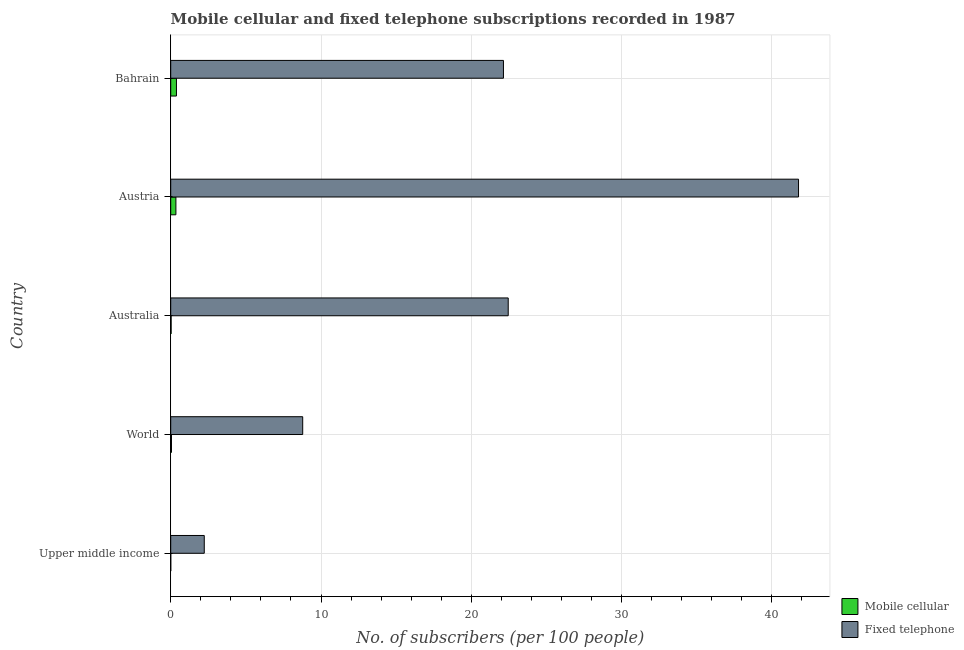How many groups of bars are there?
Give a very brief answer. 5. How many bars are there on the 5th tick from the top?
Your answer should be compact. 2. What is the label of the 1st group of bars from the top?
Offer a very short reply. Bahrain. In how many cases, is the number of bars for a given country not equal to the number of legend labels?
Provide a short and direct response. 0. What is the number of mobile cellular subscribers in Austria?
Give a very brief answer. 0.35. Across all countries, what is the maximum number of fixed telephone subscribers?
Make the answer very short. 41.78. Across all countries, what is the minimum number of mobile cellular subscribers?
Provide a succinct answer. 0. In which country was the number of mobile cellular subscribers maximum?
Offer a very short reply. Bahrain. In which country was the number of mobile cellular subscribers minimum?
Keep it short and to the point. Upper middle income. What is the total number of fixed telephone subscribers in the graph?
Your response must be concise. 97.39. What is the difference between the number of mobile cellular subscribers in Australia and that in Austria?
Your answer should be compact. -0.32. What is the difference between the number of mobile cellular subscribers in Australia and the number of fixed telephone subscribers in Bahrain?
Ensure brevity in your answer.  -22.11. What is the average number of fixed telephone subscribers per country?
Your answer should be compact. 19.48. What is the difference between the number of mobile cellular subscribers and number of fixed telephone subscribers in Bahrain?
Make the answer very short. -21.76. In how many countries, is the number of mobile cellular subscribers greater than 2 ?
Keep it short and to the point. 0. What is the ratio of the number of fixed telephone subscribers in Australia to that in World?
Your answer should be very brief. 2.56. Is the number of mobile cellular subscribers in Australia less than that in Upper middle income?
Your answer should be compact. No. Is the difference between the number of fixed telephone subscribers in Australia and Bahrain greater than the difference between the number of mobile cellular subscribers in Australia and Bahrain?
Offer a very short reply. Yes. What is the difference between the highest and the second highest number of fixed telephone subscribers?
Offer a very short reply. 19.32. What is the difference between the highest and the lowest number of mobile cellular subscribers?
Provide a succinct answer. 0.38. Is the sum of the number of fixed telephone subscribers in Bahrain and Upper middle income greater than the maximum number of mobile cellular subscribers across all countries?
Offer a very short reply. Yes. What does the 2nd bar from the top in World represents?
Offer a very short reply. Mobile cellular. What does the 1st bar from the bottom in Upper middle income represents?
Give a very brief answer. Mobile cellular. How many countries are there in the graph?
Make the answer very short. 5. What is the difference between two consecutive major ticks on the X-axis?
Provide a succinct answer. 10. Are the values on the major ticks of X-axis written in scientific E-notation?
Your answer should be very brief. No. Does the graph contain any zero values?
Offer a very short reply. No. How many legend labels are there?
Your response must be concise. 2. How are the legend labels stacked?
Make the answer very short. Vertical. What is the title of the graph?
Your response must be concise. Mobile cellular and fixed telephone subscriptions recorded in 1987. Does "Technicians" appear as one of the legend labels in the graph?
Your answer should be very brief. No. What is the label or title of the X-axis?
Ensure brevity in your answer.  No. of subscribers (per 100 people). What is the label or title of the Y-axis?
Your answer should be compact. Country. What is the No. of subscribers (per 100 people) in Mobile cellular in Upper middle income?
Make the answer very short. 0. What is the No. of subscribers (per 100 people) in Fixed telephone in Upper middle income?
Your response must be concise. 2.23. What is the No. of subscribers (per 100 people) of Mobile cellular in World?
Your response must be concise. 0.05. What is the No. of subscribers (per 100 people) of Fixed telephone in World?
Your answer should be compact. 8.78. What is the No. of subscribers (per 100 people) of Mobile cellular in Australia?
Offer a very short reply. 0.03. What is the No. of subscribers (per 100 people) in Fixed telephone in Australia?
Your response must be concise. 22.46. What is the No. of subscribers (per 100 people) in Mobile cellular in Austria?
Make the answer very short. 0.35. What is the No. of subscribers (per 100 people) in Fixed telephone in Austria?
Offer a terse response. 41.78. What is the No. of subscribers (per 100 people) of Mobile cellular in Bahrain?
Your answer should be very brief. 0.38. What is the No. of subscribers (per 100 people) of Fixed telephone in Bahrain?
Your response must be concise. 22.14. Across all countries, what is the maximum No. of subscribers (per 100 people) of Mobile cellular?
Ensure brevity in your answer.  0.38. Across all countries, what is the maximum No. of subscribers (per 100 people) of Fixed telephone?
Provide a succinct answer. 41.78. Across all countries, what is the minimum No. of subscribers (per 100 people) in Mobile cellular?
Your answer should be compact. 0. Across all countries, what is the minimum No. of subscribers (per 100 people) of Fixed telephone?
Your answer should be compact. 2.23. What is the total No. of subscribers (per 100 people) in Mobile cellular in the graph?
Offer a very short reply. 0.81. What is the total No. of subscribers (per 100 people) in Fixed telephone in the graph?
Give a very brief answer. 97.39. What is the difference between the No. of subscribers (per 100 people) in Mobile cellular in Upper middle income and that in World?
Ensure brevity in your answer.  -0.05. What is the difference between the No. of subscribers (per 100 people) in Fixed telephone in Upper middle income and that in World?
Give a very brief answer. -6.55. What is the difference between the No. of subscribers (per 100 people) of Mobile cellular in Upper middle income and that in Australia?
Give a very brief answer. -0.03. What is the difference between the No. of subscribers (per 100 people) of Fixed telephone in Upper middle income and that in Australia?
Offer a very short reply. -20.23. What is the difference between the No. of subscribers (per 100 people) in Mobile cellular in Upper middle income and that in Austria?
Your answer should be very brief. -0.34. What is the difference between the No. of subscribers (per 100 people) of Fixed telephone in Upper middle income and that in Austria?
Offer a terse response. -39.54. What is the difference between the No. of subscribers (per 100 people) in Mobile cellular in Upper middle income and that in Bahrain?
Provide a succinct answer. -0.38. What is the difference between the No. of subscribers (per 100 people) in Fixed telephone in Upper middle income and that in Bahrain?
Make the answer very short. -19.91. What is the difference between the No. of subscribers (per 100 people) in Mobile cellular in World and that in Australia?
Provide a succinct answer. 0.02. What is the difference between the No. of subscribers (per 100 people) in Fixed telephone in World and that in Australia?
Your answer should be compact. -13.68. What is the difference between the No. of subscribers (per 100 people) of Mobile cellular in World and that in Austria?
Your response must be concise. -0.29. What is the difference between the No. of subscribers (per 100 people) in Fixed telephone in World and that in Austria?
Your answer should be compact. -32.99. What is the difference between the No. of subscribers (per 100 people) of Mobile cellular in World and that in Bahrain?
Provide a short and direct response. -0.33. What is the difference between the No. of subscribers (per 100 people) in Fixed telephone in World and that in Bahrain?
Offer a terse response. -13.36. What is the difference between the No. of subscribers (per 100 people) in Mobile cellular in Australia and that in Austria?
Ensure brevity in your answer.  -0.32. What is the difference between the No. of subscribers (per 100 people) in Fixed telephone in Australia and that in Austria?
Offer a very short reply. -19.32. What is the difference between the No. of subscribers (per 100 people) of Mobile cellular in Australia and that in Bahrain?
Make the answer very short. -0.35. What is the difference between the No. of subscribers (per 100 people) in Fixed telephone in Australia and that in Bahrain?
Give a very brief answer. 0.32. What is the difference between the No. of subscribers (per 100 people) in Mobile cellular in Austria and that in Bahrain?
Make the answer very short. -0.04. What is the difference between the No. of subscribers (per 100 people) of Fixed telephone in Austria and that in Bahrain?
Keep it short and to the point. 19.64. What is the difference between the No. of subscribers (per 100 people) of Mobile cellular in Upper middle income and the No. of subscribers (per 100 people) of Fixed telephone in World?
Your answer should be very brief. -8.78. What is the difference between the No. of subscribers (per 100 people) in Mobile cellular in Upper middle income and the No. of subscribers (per 100 people) in Fixed telephone in Australia?
Offer a very short reply. -22.46. What is the difference between the No. of subscribers (per 100 people) in Mobile cellular in Upper middle income and the No. of subscribers (per 100 people) in Fixed telephone in Austria?
Your answer should be very brief. -41.77. What is the difference between the No. of subscribers (per 100 people) in Mobile cellular in Upper middle income and the No. of subscribers (per 100 people) in Fixed telephone in Bahrain?
Your answer should be compact. -22.14. What is the difference between the No. of subscribers (per 100 people) in Mobile cellular in World and the No. of subscribers (per 100 people) in Fixed telephone in Australia?
Offer a terse response. -22.41. What is the difference between the No. of subscribers (per 100 people) of Mobile cellular in World and the No. of subscribers (per 100 people) of Fixed telephone in Austria?
Offer a very short reply. -41.73. What is the difference between the No. of subscribers (per 100 people) in Mobile cellular in World and the No. of subscribers (per 100 people) in Fixed telephone in Bahrain?
Give a very brief answer. -22.09. What is the difference between the No. of subscribers (per 100 people) in Mobile cellular in Australia and the No. of subscribers (per 100 people) in Fixed telephone in Austria?
Provide a short and direct response. -41.75. What is the difference between the No. of subscribers (per 100 people) of Mobile cellular in Australia and the No. of subscribers (per 100 people) of Fixed telephone in Bahrain?
Provide a succinct answer. -22.11. What is the difference between the No. of subscribers (per 100 people) of Mobile cellular in Austria and the No. of subscribers (per 100 people) of Fixed telephone in Bahrain?
Make the answer very short. -21.8. What is the average No. of subscribers (per 100 people) in Mobile cellular per country?
Offer a very short reply. 0.16. What is the average No. of subscribers (per 100 people) of Fixed telephone per country?
Your answer should be very brief. 19.48. What is the difference between the No. of subscribers (per 100 people) in Mobile cellular and No. of subscribers (per 100 people) in Fixed telephone in Upper middle income?
Your answer should be very brief. -2.23. What is the difference between the No. of subscribers (per 100 people) of Mobile cellular and No. of subscribers (per 100 people) of Fixed telephone in World?
Provide a short and direct response. -8.73. What is the difference between the No. of subscribers (per 100 people) of Mobile cellular and No. of subscribers (per 100 people) of Fixed telephone in Australia?
Your answer should be compact. -22.43. What is the difference between the No. of subscribers (per 100 people) of Mobile cellular and No. of subscribers (per 100 people) of Fixed telephone in Austria?
Give a very brief answer. -41.43. What is the difference between the No. of subscribers (per 100 people) in Mobile cellular and No. of subscribers (per 100 people) in Fixed telephone in Bahrain?
Your answer should be very brief. -21.76. What is the ratio of the No. of subscribers (per 100 people) of Mobile cellular in Upper middle income to that in World?
Provide a short and direct response. 0.03. What is the ratio of the No. of subscribers (per 100 people) in Fixed telephone in Upper middle income to that in World?
Your response must be concise. 0.25. What is the ratio of the No. of subscribers (per 100 people) of Mobile cellular in Upper middle income to that in Australia?
Your response must be concise. 0.06. What is the ratio of the No. of subscribers (per 100 people) of Fixed telephone in Upper middle income to that in Australia?
Provide a short and direct response. 0.1. What is the ratio of the No. of subscribers (per 100 people) of Mobile cellular in Upper middle income to that in Austria?
Make the answer very short. 0. What is the ratio of the No. of subscribers (per 100 people) in Fixed telephone in Upper middle income to that in Austria?
Your answer should be very brief. 0.05. What is the ratio of the No. of subscribers (per 100 people) in Mobile cellular in Upper middle income to that in Bahrain?
Keep it short and to the point. 0. What is the ratio of the No. of subscribers (per 100 people) in Fixed telephone in Upper middle income to that in Bahrain?
Provide a short and direct response. 0.1. What is the ratio of the No. of subscribers (per 100 people) of Mobile cellular in World to that in Australia?
Provide a short and direct response. 1.88. What is the ratio of the No. of subscribers (per 100 people) of Fixed telephone in World to that in Australia?
Offer a terse response. 0.39. What is the ratio of the No. of subscribers (per 100 people) in Mobile cellular in World to that in Austria?
Offer a terse response. 0.15. What is the ratio of the No. of subscribers (per 100 people) in Fixed telephone in World to that in Austria?
Your answer should be very brief. 0.21. What is the ratio of the No. of subscribers (per 100 people) in Mobile cellular in World to that in Bahrain?
Your answer should be very brief. 0.13. What is the ratio of the No. of subscribers (per 100 people) in Fixed telephone in World to that in Bahrain?
Provide a short and direct response. 0.4. What is the ratio of the No. of subscribers (per 100 people) in Mobile cellular in Australia to that in Austria?
Give a very brief answer. 0.08. What is the ratio of the No. of subscribers (per 100 people) in Fixed telephone in Australia to that in Austria?
Offer a very short reply. 0.54. What is the ratio of the No. of subscribers (per 100 people) of Mobile cellular in Australia to that in Bahrain?
Your response must be concise. 0.07. What is the ratio of the No. of subscribers (per 100 people) of Fixed telephone in Australia to that in Bahrain?
Give a very brief answer. 1.01. What is the ratio of the No. of subscribers (per 100 people) in Mobile cellular in Austria to that in Bahrain?
Offer a terse response. 0.91. What is the ratio of the No. of subscribers (per 100 people) in Fixed telephone in Austria to that in Bahrain?
Offer a terse response. 1.89. What is the difference between the highest and the second highest No. of subscribers (per 100 people) in Mobile cellular?
Provide a succinct answer. 0.04. What is the difference between the highest and the second highest No. of subscribers (per 100 people) in Fixed telephone?
Your response must be concise. 19.32. What is the difference between the highest and the lowest No. of subscribers (per 100 people) in Mobile cellular?
Offer a very short reply. 0.38. What is the difference between the highest and the lowest No. of subscribers (per 100 people) in Fixed telephone?
Your response must be concise. 39.54. 